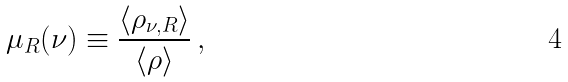Convert formula to latex. <formula><loc_0><loc_0><loc_500><loc_500>\mu _ { R } ( \nu ) \equiv \frac { \langle \rho _ { \nu , R } \rangle } { \langle \rho \rangle } \, ,</formula> 